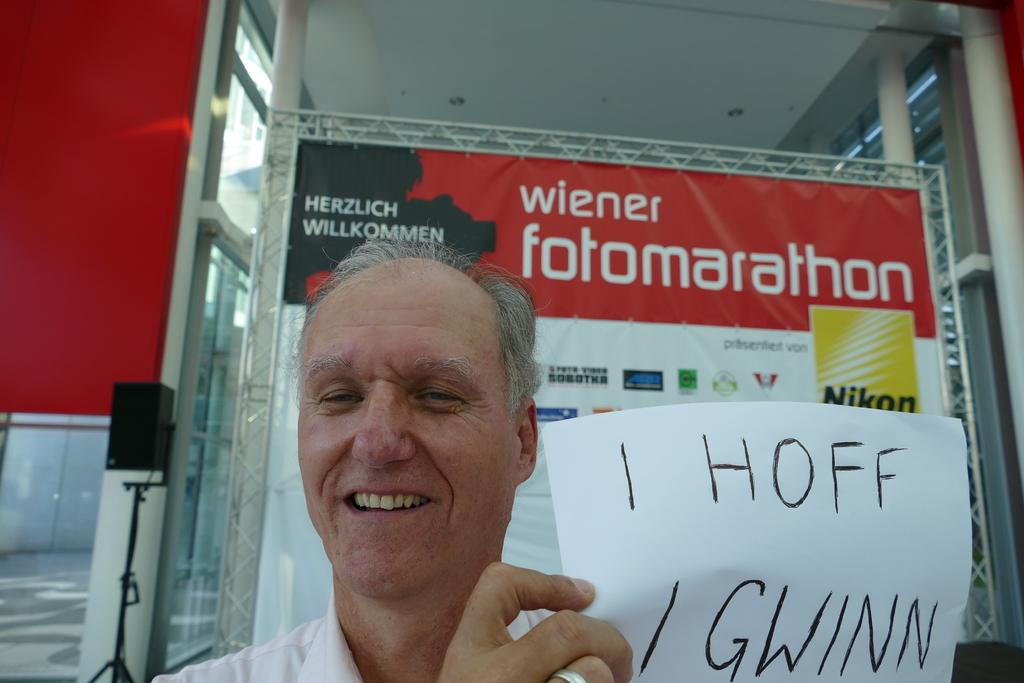Who is present in the image? There is a man in the image. What is the man doing in the image? The man is smiling and holding a paper. What objects can be seen in the image besides the man? There is a speaker with a stand and a banner truss in the image. How many sisters does the man have in the image? There is no information about the man's sisters in the image, as it only shows him smiling, holding a paper, and standing near a speaker with a stand and a banner truss. 